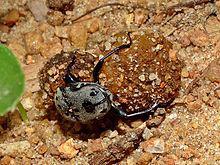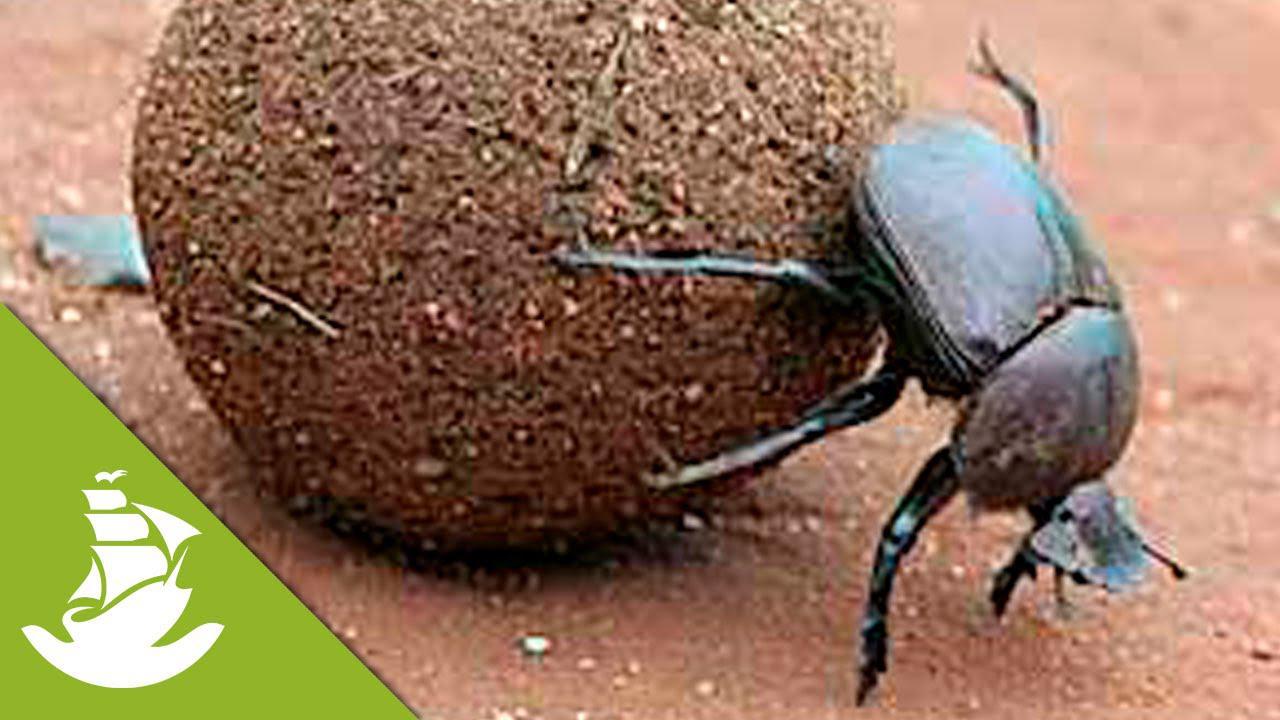The first image is the image on the left, the second image is the image on the right. Examine the images to the left and right. Is the description "There is a bug in each image on a ball of sediment." accurate? Answer yes or no. Yes. The first image is the image on the left, the second image is the image on the right. Assess this claim about the two images: "there are two insects in the image on the left.". Correct or not? Answer yes or no. No. The first image is the image on the left, the second image is the image on the right. For the images shown, is this caption "There is no ball in the image on the left" true? Answer yes or no. No. The first image is the image on the left, the second image is the image on the right. Analyze the images presented: Is the assertion "In one image, one beetle is on the ground next to a beetle on a dung ball." valid? Answer yes or no. No. 